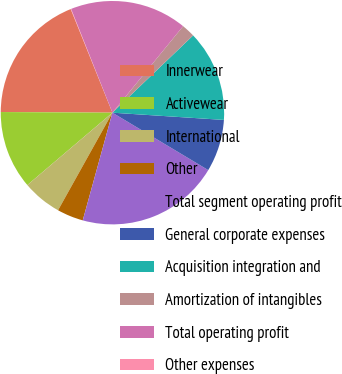Convert chart. <chart><loc_0><loc_0><loc_500><loc_500><pie_chart><fcel>Innerwear<fcel>Activewear<fcel>International<fcel>Other<fcel>Total segment operating profit<fcel>General corporate expenses<fcel>Acquisition integration and<fcel>Amortization of intangibles<fcel>Total operating profit<fcel>Other expenses<nl><fcel>18.81%<fcel>11.31%<fcel>5.69%<fcel>3.81%<fcel>20.69%<fcel>7.56%<fcel>13.19%<fcel>1.94%<fcel>16.94%<fcel>0.06%<nl></chart> 